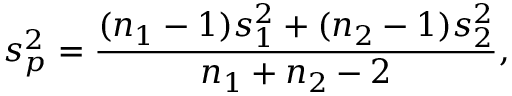Convert formula to latex. <formula><loc_0><loc_0><loc_500><loc_500>s _ { p } ^ { 2 } = { \frac { ( n _ { 1 } - 1 ) s _ { 1 } ^ { 2 } + ( n _ { 2 } - 1 ) s _ { 2 } ^ { 2 } } { n _ { 1 } + n _ { 2 } - 2 } } ,</formula> 